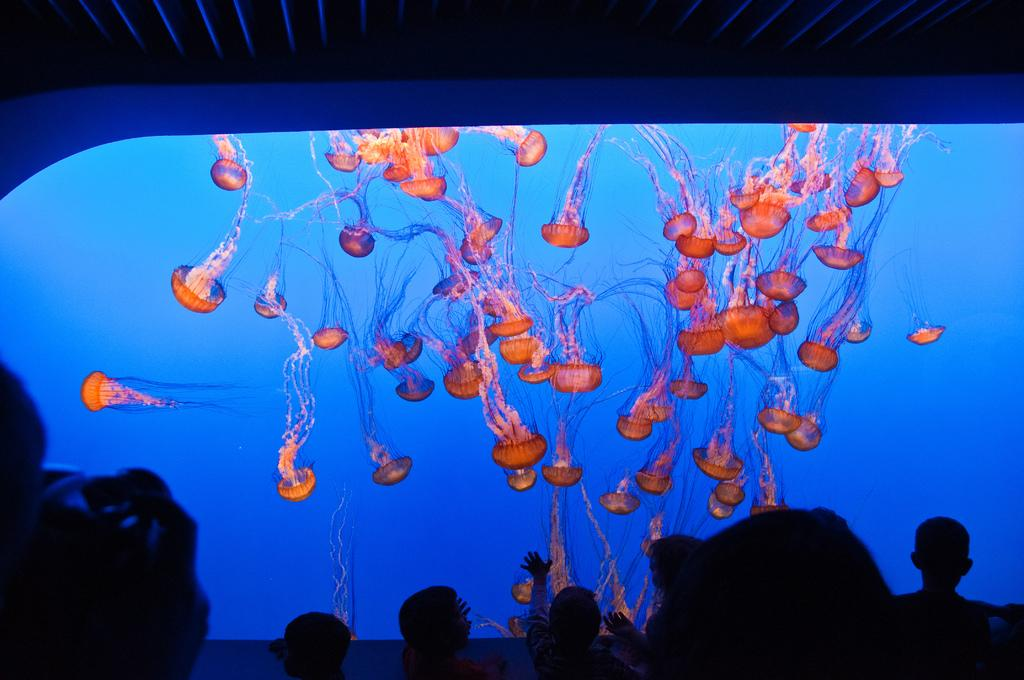Where was the image taken? The image was taken in a theater. What can be seen at the bottom of the image? There are people at the bottom of the image. What is the main feature in the center of the image? There is a screen in the center of the image. What is being displayed on the screen? Jellyfish are displayed on the screen. What part of the theater can be seen at the top of the image? There is a ceiling visible at the top of the image. Can you see an ant carrying a rake in the image? No, there is no ant or rake present in the image. Is there a man standing next to the screen in the image? The provided facts do not mention a man standing next to the screen, so we cannot confirm or deny his presence. 